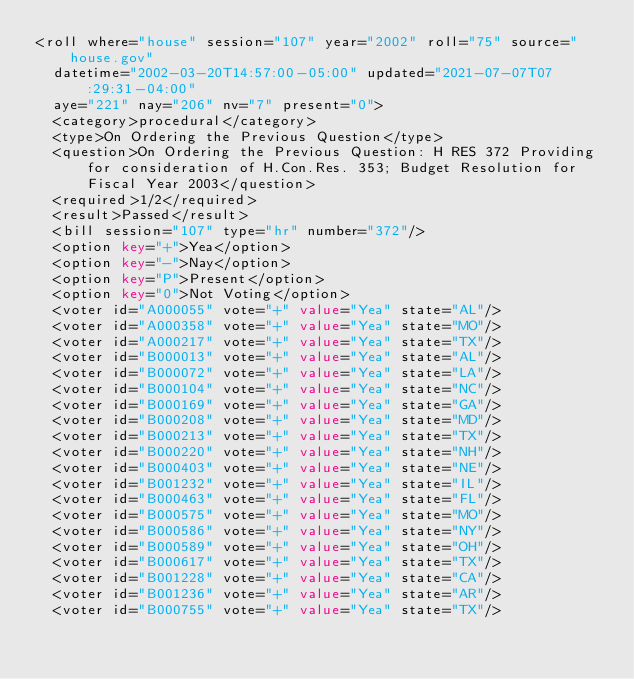Convert code to text. <code><loc_0><loc_0><loc_500><loc_500><_XML_><roll where="house" session="107" year="2002" roll="75" source="house.gov"
  datetime="2002-03-20T14:57:00-05:00" updated="2021-07-07T07:29:31-04:00"
  aye="221" nay="206" nv="7" present="0">
  <category>procedural</category>
  <type>On Ordering the Previous Question</type>
  <question>On Ordering the Previous Question: H RES 372 Providing for consideration of H.Con.Res. 353; Budget Resolution for Fiscal Year 2003</question>
  <required>1/2</required>
  <result>Passed</result>
  <bill session="107" type="hr" number="372"/>
  <option key="+">Yea</option>
  <option key="-">Nay</option>
  <option key="P">Present</option>
  <option key="0">Not Voting</option>
  <voter id="A000055" vote="+" value="Yea" state="AL"/>
  <voter id="A000358" vote="+" value="Yea" state="MO"/>
  <voter id="A000217" vote="+" value="Yea" state="TX"/>
  <voter id="B000013" vote="+" value="Yea" state="AL"/>
  <voter id="B000072" vote="+" value="Yea" state="LA"/>
  <voter id="B000104" vote="+" value="Yea" state="NC"/>
  <voter id="B000169" vote="+" value="Yea" state="GA"/>
  <voter id="B000208" vote="+" value="Yea" state="MD"/>
  <voter id="B000213" vote="+" value="Yea" state="TX"/>
  <voter id="B000220" vote="+" value="Yea" state="NH"/>
  <voter id="B000403" vote="+" value="Yea" state="NE"/>
  <voter id="B001232" vote="+" value="Yea" state="IL"/>
  <voter id="B000463" vote="+" value="Yea" state="FL"/>
  <voter id="B000575" vote="+" value="Yea" state="MO"/>
  <voter id="B000586" vote="+" value="Yea" state="NY"/>
  <voter id="B000589" vote="+" value="Yea" state="OH"/>
  <voter id="B000617" vote="+" value="Yea" state="TX"/>
  <voter id="B001228" vote="+" value="Yea" state="CA"/>
  <voter id="B001236" vote="+" value="Yea" state="AR"/>
  <voter id="B000755" vote="+" value="Yea" state="TX"/></code> 